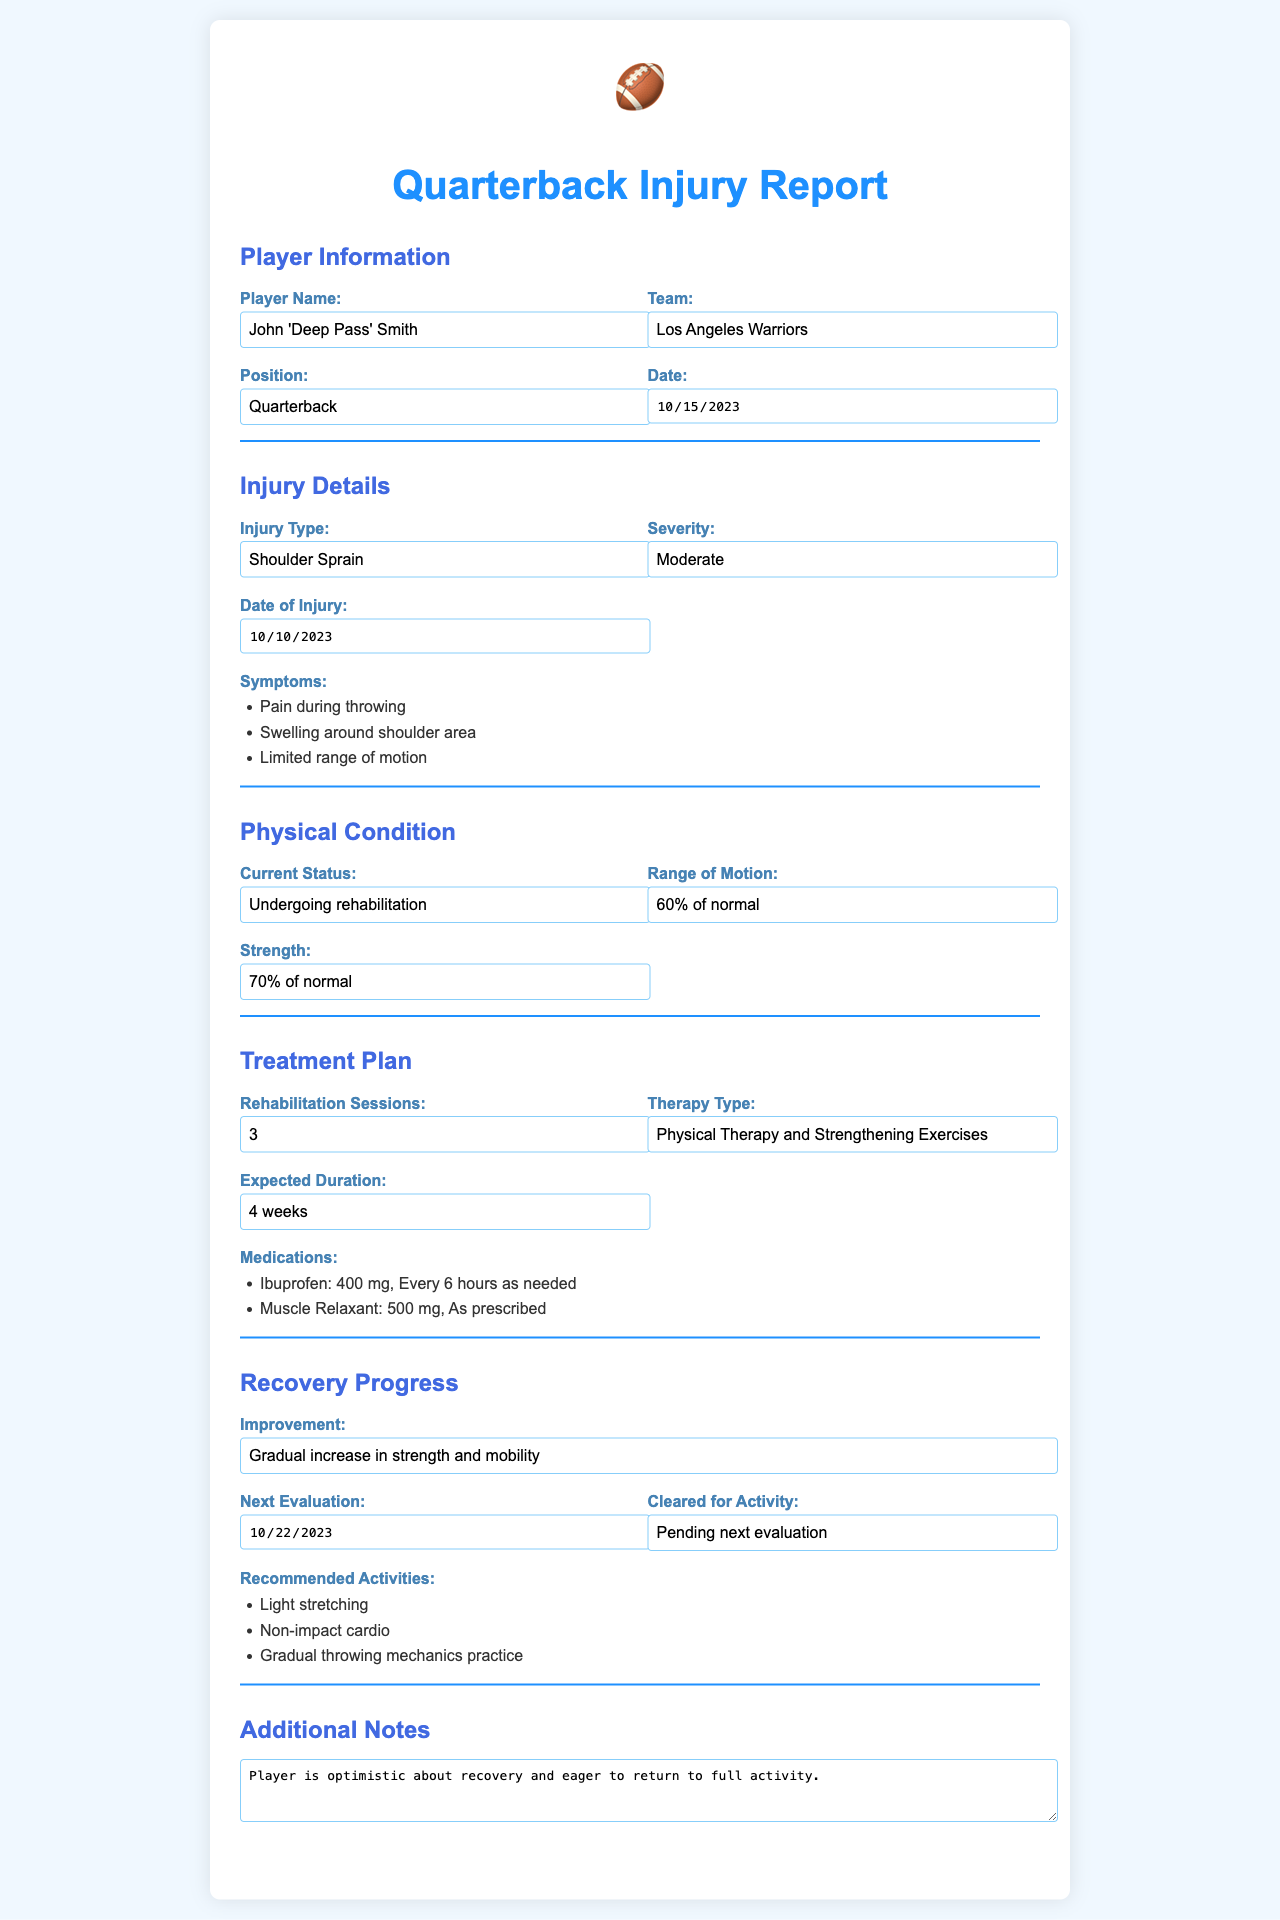What is the player's name? The player's name is found in the Player Information section of the document.
Answer: John 'Deep Pass' Smith What is the injury type? The injury type is listed under Injury Details in the document.
Answer: Shoulder Sprain What is the date of injury? The date of injury is specified in the Injury Details section of the document.
Answer: 2023-10-10 What is the current strength percentage? The current strength percentage is detailed in the Physical Condition section of the document.
Answer: 70% of normal How many rehabilitation sessions are planned? The number of rehabilitation sessions is indicated in the Treatment Plan section of the document.
Answer: 3 What is the expected duration of recovery? The expected duration is mentioned under the Treatment Plan section.
Answer: 4 weeks What is the next evaluation date? The next evaluation date is listed in the Recovery Progress section of the document.
Answer: 2023-10-22 What medications are prescribed? The medications prescribed are noted in the Treatment Plan section, showing specifics for dosage and frequency.
Answer: Ibuprofen: 400 mg, Muscle Relaxant: 500 mg What activities are recommended? The recommended activities are found in the Recovery Progress section, outlining specific exercises.
Answer: Light stretching, Non-impact cardio, Gradual throwing mechanics practice What is the player's condition regarding activity clearance? The status of the player's activity clearance is detailed in the Recovery Progress section of the document.
Answer: Pending next evaluation 